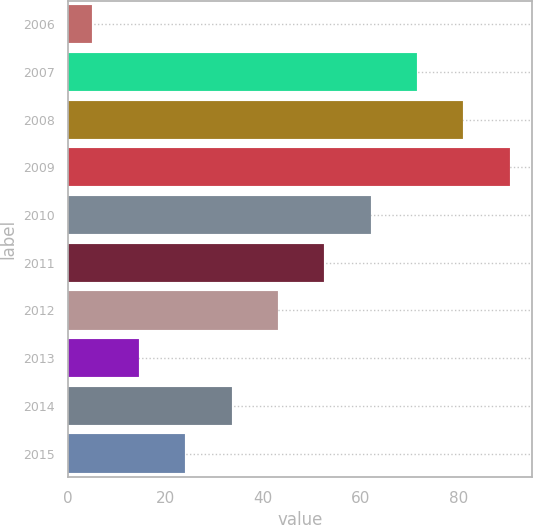Convert chart. <chart><loc_0><loc_0><loc_500><loc_500><bar_chart><fcel>2006<fcel>2007<fcel>2008<fcel>2009<fcel>2010<fcel>2011<fcel>2012<fcel>2013<fcel>2014<fcel>2015<nl><fcel>5<fcel>71.5<fcel>81<fcel>90.5<fcel>62<fcel>52.5<fcel>43<fcel>14.5<fcel>33.5<fcel>24<nl></chart> 